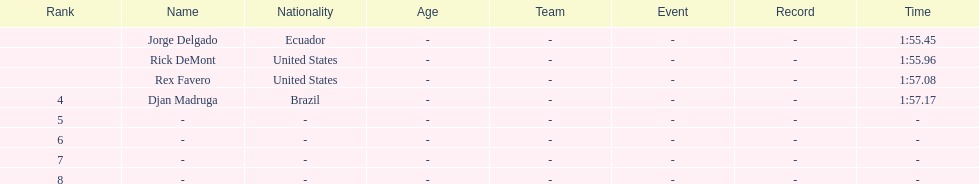Would you be able to parse every entry in this table? {'header': ['Rank', 'Name', 'Nationality', 'Age', 'Team', 'Event', 'Record', 'Time'], 'rows': [['', 'Jorge Delgado', 'Ecuador', '-', '-', '-', '-', '1:55.45'], ['', 'Rick DeMont', 'United States', '-', '-', '-', '-', '1:55.96'], ['', 'Rex Favero', 'United States', '-', '-', '-', '-', '1:57.08'], ['4', 'Djan Madruga', 'Brazil', '-', '-', '-', '-', '1:57.17'], ['5', '-', '-', '-', '-', '-', '-', '-'], ['6', '-', '-', '-', '-', '-', '-', '-'], ['7', '-', '-', '-', '-', '-', '-', '-'], ['8', '-', '-', '-', '-', '-', '-', '-']]} What is the time for each name 1:55.45, 1:55.96, 1:57.08, 1:57.17. 